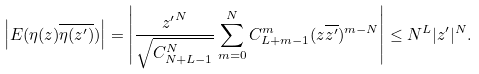<formula> <loc_0><loc_0><loc_500><loc_500>\left | E ( \eta ( z ) \overline { \eta ( z ^ { \prime } ) } ) \right | = \left | \frac { { z ^ { \prime } } ^ { N } } { \sqrt { C _ { N + L - 1 } ^ { N } } } \sum _ { m = 0 } ^ { N } C _ { L + m - 1 } ^ { m } ( z \overline { z ^ { \prime } } ) ^ { m - N } \right | \leq { N ^ { L } } { | z ^ { \prime } | ^ { N } } .</formula> 